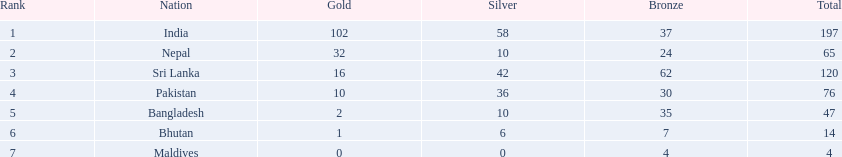How many gold medals were awarded between all 7 nations? 163. 